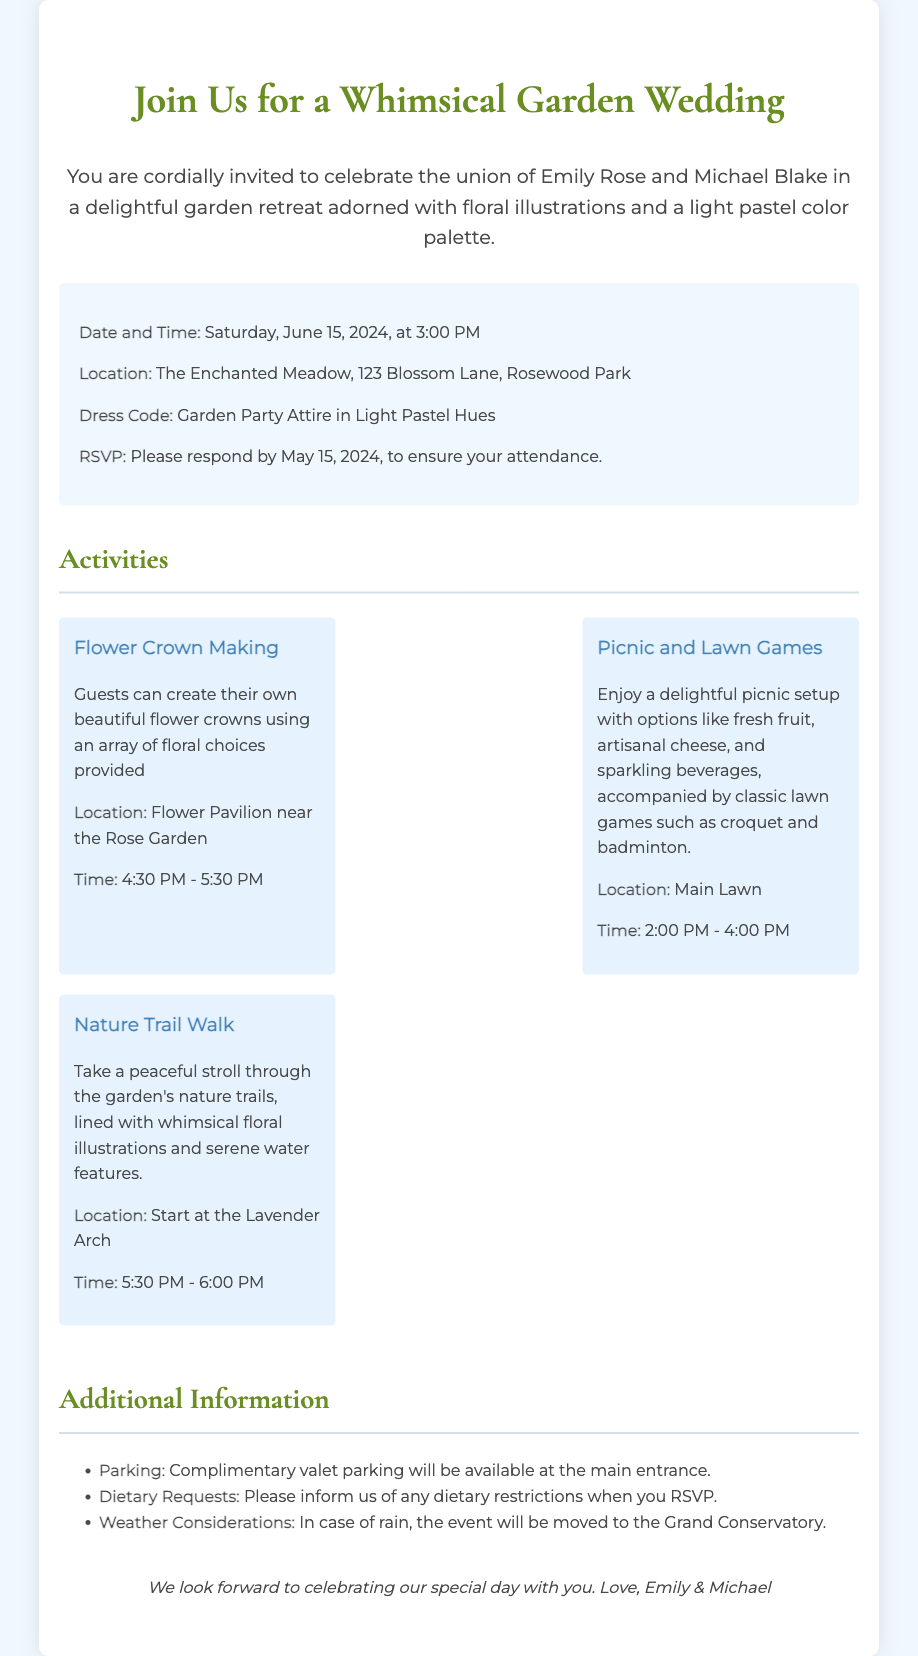What is the date of the wedding? The document states that the wedding will take place on Saturday, June 15, 2024.
Answer: June 15, 2024 Where is the wedding being held? The location of the wedding is provided in the document as The Enchanted Meadow.
Answer: The Enchanted Meadow What time does the picnic and lawn games activity start? The picnic and lawn games activity is scheduled to begin at 2:00 PM as indicated in the document.
Answer: 2:00 PM What is the dress code for the wedding? The document outlines the dress code, which is Garden Party Attire in Light Pastel Hues.
Answer: Garden Party Attire in Light Pastel Hues What activity involves creating flower crowns? The document mentions the activity called Flower Crown Making, where guests can design their own flower crowns.
Answer: Flower Crown Making How long is the Nature Trail Walk scheduled for? The Nature Trail Walk is set to occur from 5:30 PM to 6:00 PM, totaling 30 minutes.
Answer: 30 minutes What type of parking is available at the event? The document mentions that Complimentary valet parking will be available at the main entrance.
Answer: Complimentary valet parking When is the RSVP deadline? The document specifies the RSVP deadline as May 15, 2024.
Answer: May 15, 2024 What will happen in case of rain? The document states that if it rains, the event will be moved to the Grand Conservatory.
Answer: Grand Conservatory 